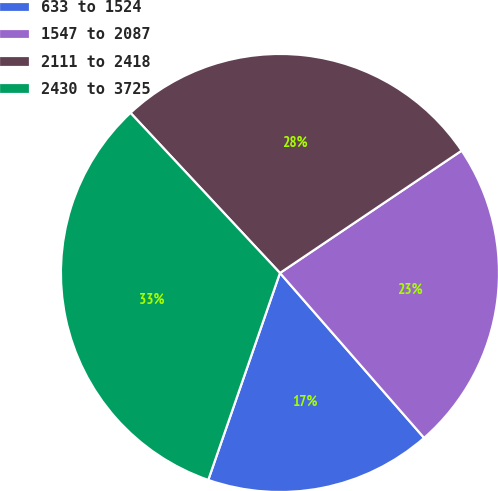<chart> <loc_0><loc_0><loc_500><loc_500><pie_chart><fcel>633 to 1524<fcel>1547 to 2087<fcel>2111 to 2418<fcel>2430 to 3725<nl><fcel>16.74%<fcel>23.0%<fcel>27.52%<fcel>32.74%<nl></chart> 